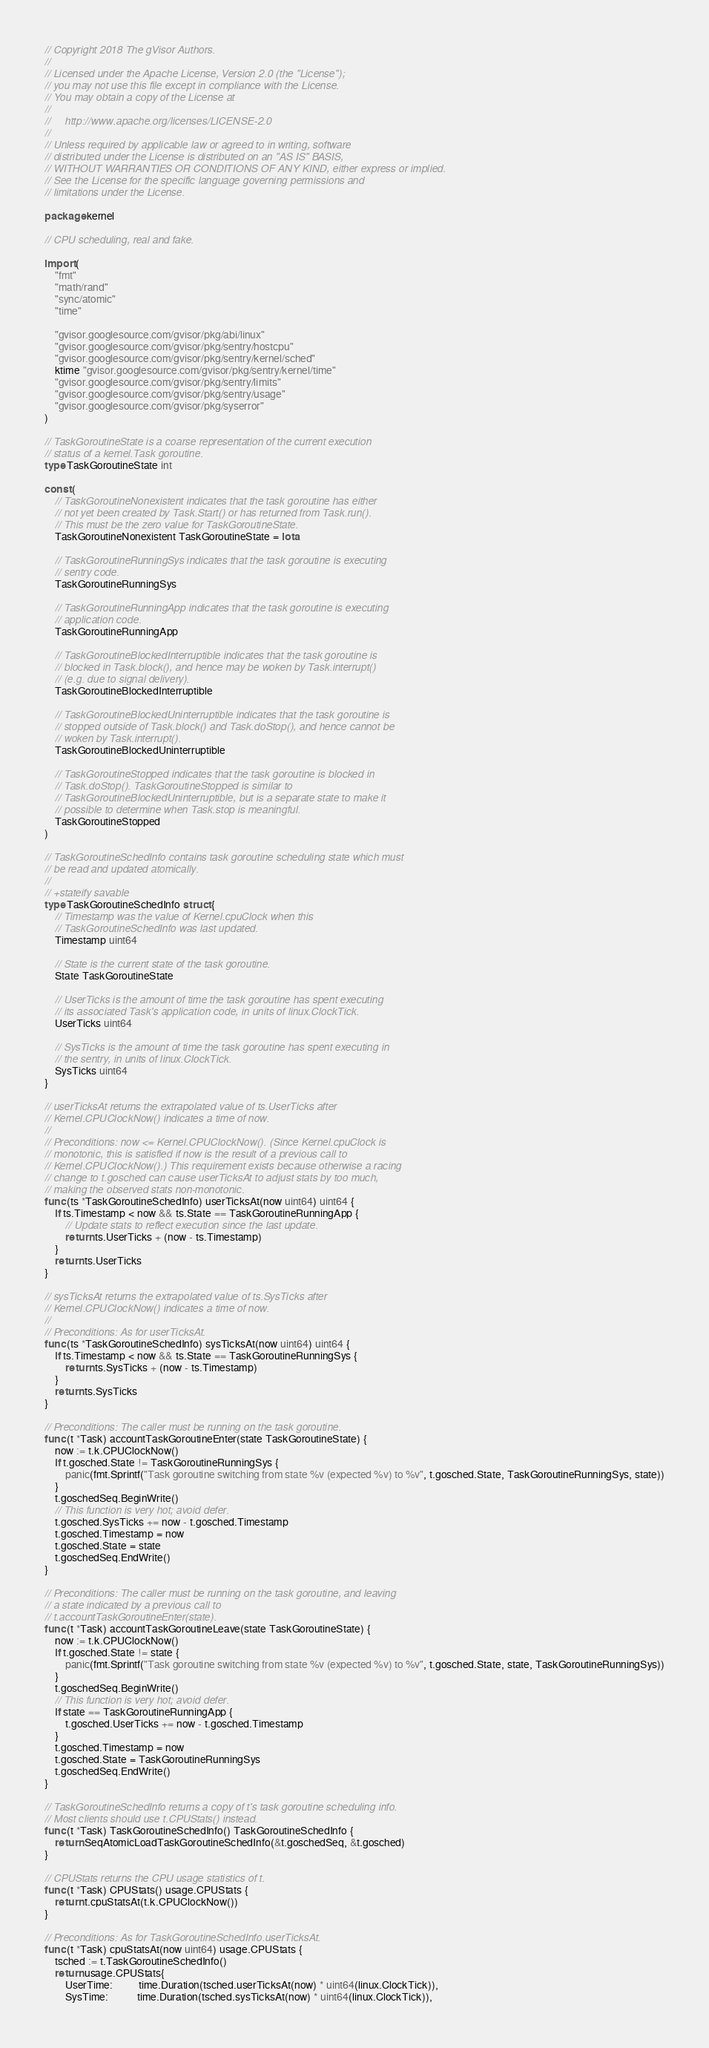<code> <loc_0><loc_0><loc_500><loc_500><_Go_>// Copyright 2018 The gVisor Authors.
//
// Licensed under the Apache License, Version 2.0 (the "License");
// you may not use this file except in compliance with the License.
// You may obtain a copy of the License at
//
//     http://www.apache.org/licenses/LICENSE-2.0
//
// Unless required by applicable law or agreed to in writing, software
// distributed under the License is distributed on an "AS IS" BASIS,
// WITHOUT WARRANTIES OR CONDITIONS OF ANY KIND, either express or implied.
// See the License for the specific language governing permissions and
// limitations under the License.

package kernel

// CPU scheduling, real and fake.

import (
	"fmt"
	"math/rand"
	"sync/atomic"
	"time"

	"gvisor.googlesource.com/gvisor/pkg/abi/linux"
	"gvisor.googlesource.com/gvisor/pkg/sentry/hostcpu"
	"gvisor.googlesource.com/gvisor/pkg/sentry/kernel/sched"
	ktime "gvisor.googlesource.com/gvisor/pkg/sentry/kernel/time"
	"gvisor.googlesource.com/gvisor/pkg/sentry/limits"
	"gvisor.googlesource.com/gvisor/pkg/sentry/usage"
	"gvisor.googlesource.com/gvisor/pkg/syserror"
)

// TaskGoroutineState is a coarse representation of the current execution
// status of a kernel.Task goroutine.
type TaskGoroutineState int

const (
	// TaskGoroutineNonexistent indicates that the task goroutine has either
	// not yet been created by Task.Start() or has returned from Task.run().
	// This must be the zero value for TaskGoroutineState.
	TaskGoroutineNonexistent TaskGoroutineState = iota

	// TaskGoroutineRunningSys indicates that the task goroutine is executing
	// sentry code.
	TaskGoroutineRunningSys

	// TaskGoroutineRunningApp indicates that the task goroutine is executing
	// application code.
	TaskGoroutineRunningApp

	// TaskGoroutineBlockedInterruptible indicates that the task goroutine is
	// blocked in Task.block(), and hence may be woken by Task.interrupt()
	// (e.g. due to signal delivery).
	TaskGoroutineBlockedInterruptible

	// TaskGoroutineBlockedUninterruptible indicates that the task goroutine is
	// stopped outside of Task.block() and Task.doStop(), and hence cannot be
	// woken by Task.interrupt().
	TaskGoroutineBlockedUninterruptible

	// TaskGoroutineStopped indicates that the task goroutine is blocked in
	// Task.doStop(). TaskGoroutineStopped is similar to
	// TaskGoroutineBlockedUninterruptible, but is a separate state to make it
	// possible to determine when Task.stop is meaningful.
	TaskGoroutineStopped
)

// TaskGoroutineSchedInfo contains task goroutine scheduling state which must
// be read and updated atomically.
//
// +stateify savable
type TaskGoroutineSchedInfo struct {
	// Timestamp was the value of Kernel.cpuClock when this
	// TaskGoroutineSchedInfo was last updated.
	Timestamp uint64

	// State is the current state of the task goroutine.
	State TaskGoroutineState

	// UserTicks is the amount of time the task goroutine has spent executing
	// its associated Task's application code, in units of linux.ClockTick.
	UserTicks uint64

	// SysTicks is the amount of time the task goroutine has spent executing in
	// the sentry, in units of linux.ClockTick.
	SysTicks uint64
}

// userTicksAt returns the extrapolated value of ts.UserTicks after
// Kernel.CPUClockNow() indicates a time of now.
//
// Preconditions: now <= Kernel.CPUClockNow(). (Since Kernel.cpuClock is
// monotonic, this is satisfied if now is the result of a previous call to
// Kernel.CPUClockNow().) This requirement exists because otherwise a racing
// change to t.gosched can cause userTicksAt to adjust stats by too much,
// making the observed stats non-monotonic.
func (ts *TaskGoroutineSchedInfo) userTicksAt(now uint64) uint64 {
	if ts.Timestamp < now && ts.State == TaskGoroutineRunningApp {
		// Update stats to reflect execution since the last update.
		return ts.UserTicks + (now - ts.Timestamp)
	}
	return ts.UserTicks
}

// sysTicksAt returns the extrapolated value of ts.SysTicks after
// Kernel.CPUClockNow() indicates a time of now.
//
// Preconditions: As for userTicksAt.
func (ts *TaskGoroutineSchedInfo) sysTicksAt(now uint64) uint64 {
	if ts.Timestamp < now && ts.State == TaskGoroutineRunningSys {
		return ts.SysTicks + (now - ts.Timestamp)
	}
	return ts.SysTicks
}

// Preconditions: The caller must be running on the task goroutine.
func (t *Task) accountTaskGoroutineEnter(state TaskGoroutineState) {
	now := t.k.CPUClockNow()
	if t.gosched.State != TaskGoroutineRunningSys {
		panic(fmt.Sprintf("Task goroutine switching from state %v (expected %v) to %v", t.gosched.State, TaskGoroutineRunningSys, state))
	}
	t.goschedSeq.BeginWrite()
	// This function is very hot; avoid defer.
	t.gosched.SysTicks += now - t.gosched.Timestamp
	t.gosched.Timestamp = now
	t.gosched.State = state
	t.goschedSeq.EndWrite()
}

// Preconditions: The caller must be running on the task goroutine, and leaving
// a state indicated by a previous call to
// t.accountTaskGoroutineEnter(state).
func (t *Task) accountTaskGoroutineLeave(state TaskGoroutineState) {
	now := t.k.CPUClockNow()
	if t.gosched.State != state {
		panic(fmt.Sprintf("Task goroutine switching from state %v (expected %v) to %v", t.gosched.State, state, TaskGoroutineRunningSys))
	}
	t.goschedSeq.BeginWrite()
	// This function is very hot; avoid defer.
	if state == TaskGoroutineRunningApp {
		t.gosched.UserTicks += now - t.gosched.Timestamp
	}
	t.gosched.Timestamp = now
	t.gosched.State = TaskGoroutineRunningSys
	t.goschedSeq.EndWrite()
}

// TaskGoroutineSchedInfo returns a copy of t's task goroutine scheduling info.
// Most clients should use t.CPUStats() instead.
func (t *Task) TaskGoroutineSchedInfo() TaskGoroutineSchedInfo {
	return SeqAtomicLoadTaskGoroutineSchedInfo(&t.goschedSeq, &t.gosched)
}

// CPUStats returns the CPU usage statistics of t.
func (t *Task) CPUStats() usage.CPUStats {
	return t.cpuStatsAt(t.k.CPUClockNow())
}

// Preconditions: As for TaskGoroutineSchedInfo.userTicksAt.
func (t *Task) cpuStatsAt(now uint64) usage.CPUStats {
	tsched := t.TaskGoroutineSchedInfo()
	return usage.CPUStats{
		UserTime:          time.Duration(tsched.userTicksAt(now) * uint64(linux.ClockTick)),
		SysTime:           time.Duration(tsched.sysTicksAt(now) * uint64(linux.ClockTick)),</code> 